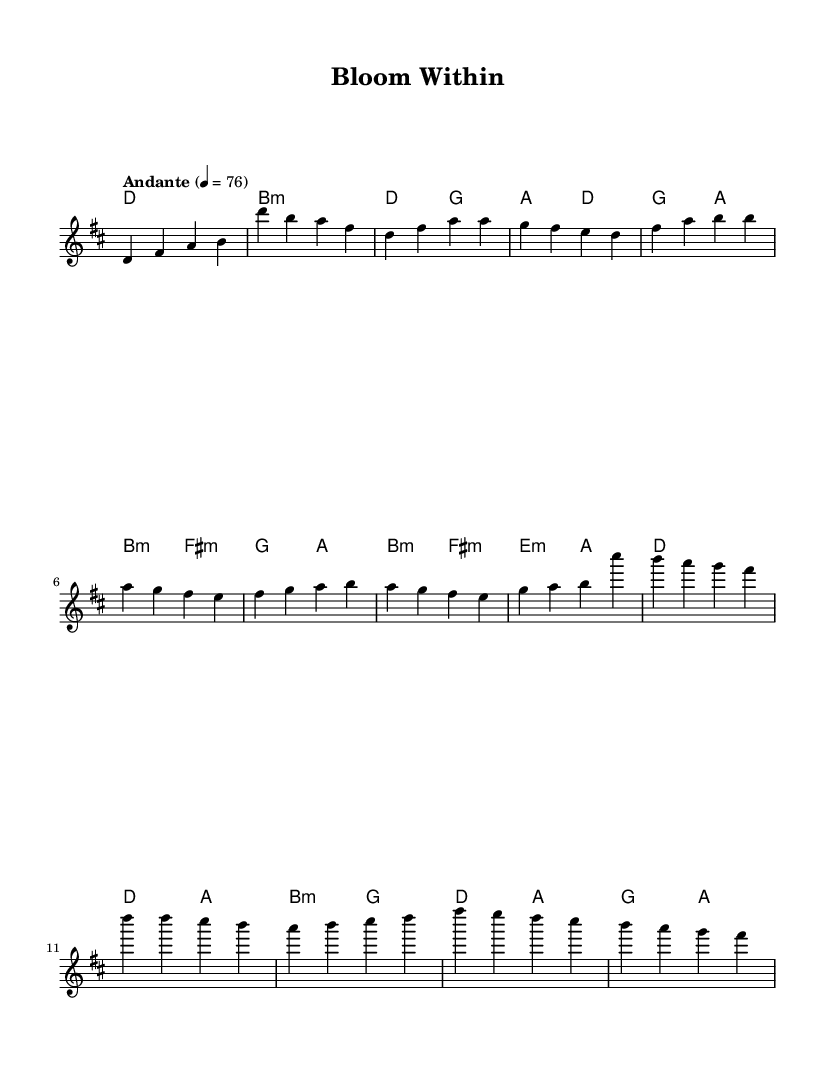What is the key signature of this music? The key signature is D major, which has two sharps (F sharp and C sharp). This can be determined from the initial part of the sheet music, where it clearly indicates 'd major'.
Answer: D major What is the time signature of this piece? The time signature is 4/4, which is shown at the beginning of the score. This means there are four beats in each measure, and it is a common time signature in pop music.
Answer: 4/4 What is the indicated tempo for this composition? The tempo is marked as "Andante" with a metronome marking of 76 beats per minute, indicating a moderately slow pace. This can be found in the tempo marking section of the score.
Answer: Andante 76 How many measures are in the provided melody? Counting the measures in the melody section, there are 9 measures visible. Each measure is separated by vertical bar lines, and upon counting them, we find a total of 9.
Answer: 9 What type of harmony is primarily used in the verse? The harmony used in the verse primarily consists of triads, particularly major and minor chords. This can be seen in the chord symbols like D major, G major, and B minor that accompany the melody.
Answer: Triads What section of the song begins with a series of eighth notes? The pre-chorus section begins with a series of eighth notes, highlighted by the note values within that specific part. The rhythmic pattern changes there, indicating a shift in the song structure.
Answer: Pre-Chorus What is the last chord in the measure before the chorus begins? The last chord before the chorus begins is A major. This can be identified as the last chord symbol present before the new melody section starts labeled as the chorus.
Answer: A major 